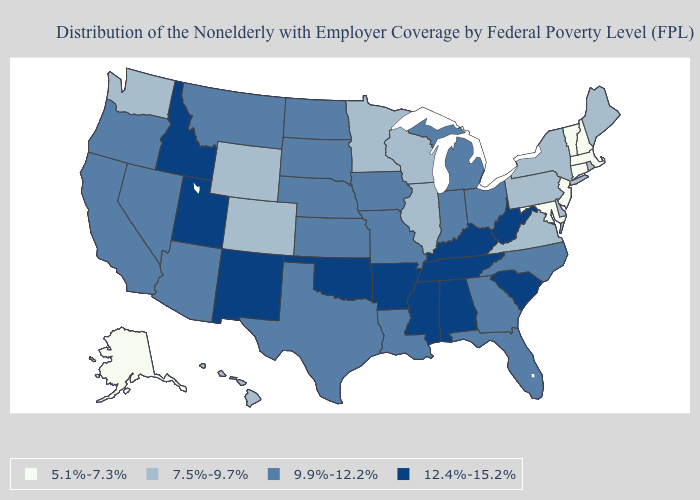Does Nevada have the lowest value in the USA?
Answer briefly. No. Which states have the lowest value in the USA?
Be succinct. Alaska, Connecticut, Maryland, Massachusetts, New Hampshire, New Jersey, Vermont. What is the value of Maryland?
Be succinct. 5.1%-7.3%. Does Wyoming have the same value as Massachusetts?
Be succinct. No. Is the legend a continuous bar?
Answer briefly. No. What is the value of Kentucky?
Give a very brief answer. 12.4%-15.2%. What is the value of Georgia?
Answer briefly. 9.9%-12.2%. Among the states that border Louisiana , does Texas have the highest value?
Keep it brief. No. Which states have the lowest value in the South?
Give a very brief answer. Maryland. What is the value of Delaware?
Quick response, please. 7.5%-9.7%. Is the legend a continuous bar?
Concise answer only. No. Is the legend a continuous bar?
Be succinct. No. What is the value of Wisconsin?
Short answer required. 7.5%-9.7%. Name the states that have a value in the range 12.4%-15.2%?
Write a very short answer. Alabama, Arkansas, Idaho, Kentucky, Mississippi, New Mexico, Oklahoma, South Carolina, Tennessee, Utah, West Virginia. 